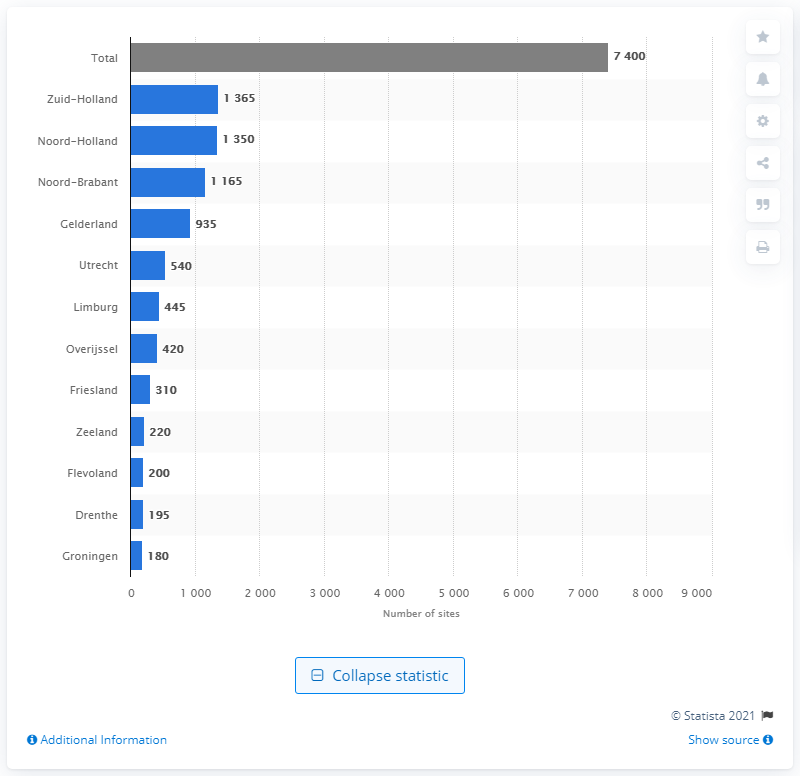List a handful of essential elements in this visual. In 2020, the province of Zuid-Holland had the most food production locations in the Netherlands. 